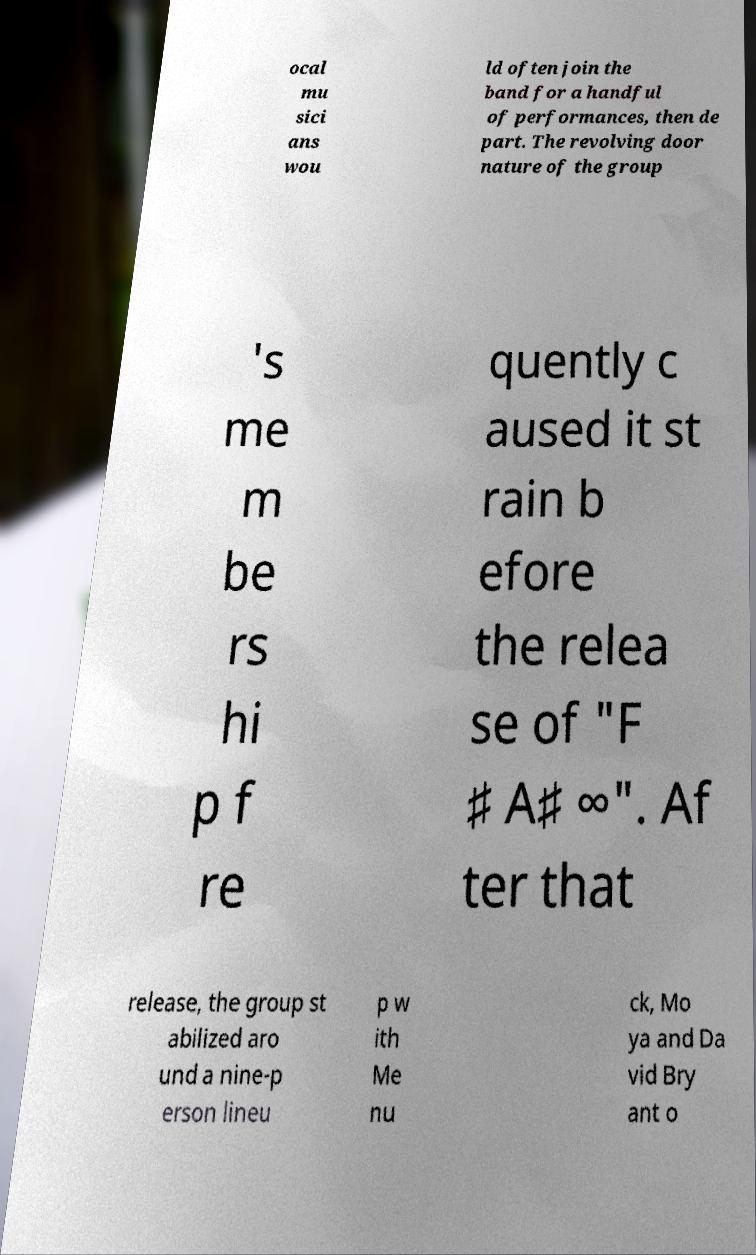Can you read and provide the text displayed in the image?This photo seems to have some interesting text. Can you extract and type it out for me? ocal mu sici ans wou ld often join the band for a handful of performances, then de part. The revolving door nature of the group 's me m be rs hi p f re quently c aused it st rain b efore the relea se of "F ♯ A♯ ∞". Af ter that release, the group st abilized aro und a nine-p erson lineu p w ith Me nu ck, Mo ya and Da vid Bry ant o 